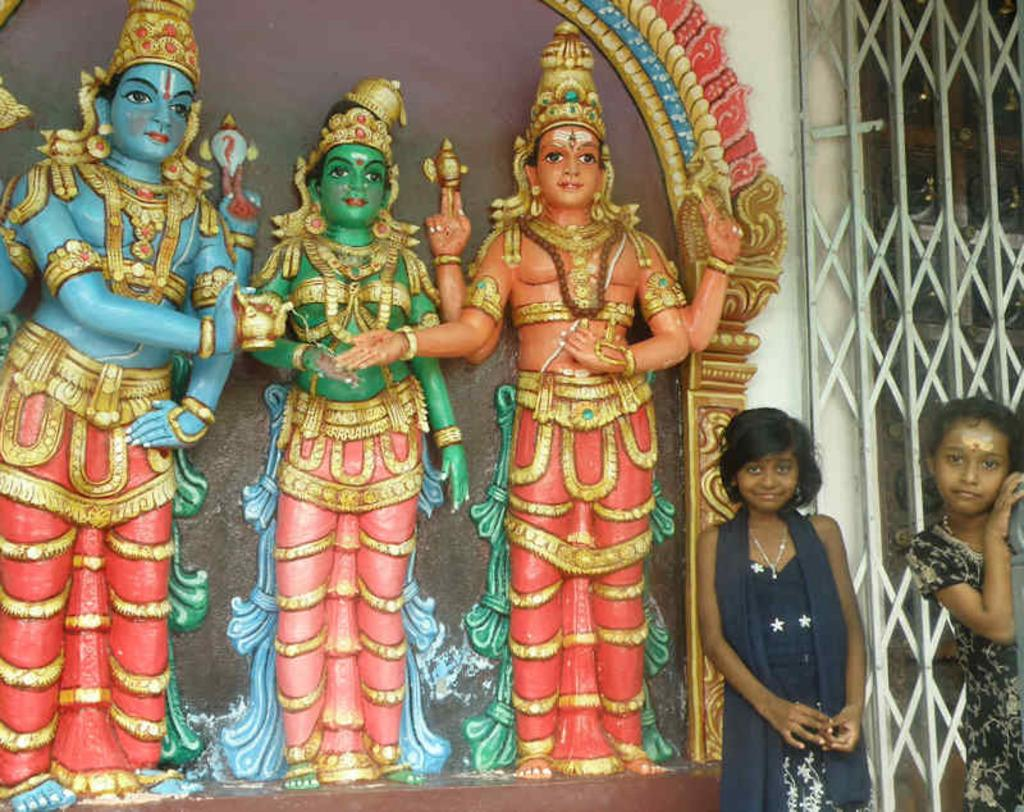What type of statues can be seen in the image? There are statues of gods in the image. Who is present near the statues? There are two kids standing beside the statues. What architectural feature is visible in the image? There is a gate attached to a wall in the image. What type of eggs are being used for the party in the image? There is no mention of eggs or a party in the image; it features statues of gods, two kids, and a gate attached to a wall. 